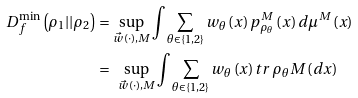<formula> <loc_0><loc_0><loc_500><loc_500>D _ { f } ^ { \min } \left ( \rho _ { 1 } | | \rho _ { 2 } \right ) & = \sup _ { \vec { w } \left ( \cdot \right ) , M } \int \sum _ { \theta \in \left \{ 1 , 2 \right \} } w _ { \theta } \left ( x \right ) p _ { \rho _ { \theta } } ^ { M } \left ( x \right ) d \mu ^ { M } \left ( x \right ) \\ & = \text { } \sup _ { \vec { w } \left ( \cdot \right ) , M } \int \sum _ { \theta \in \left \{ 1 , 2 \right \} } w _ { \theta } \left ( x \right ) t r \, \rho _ { \theta } M \left ( d x \right )</formula> 